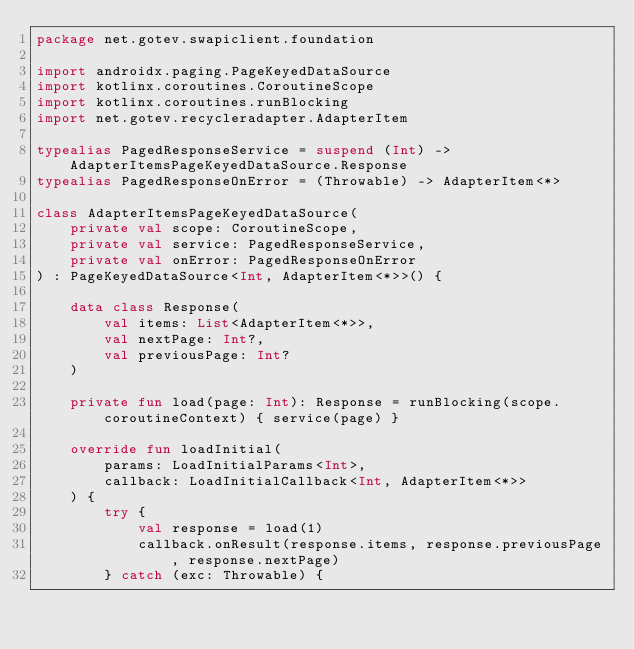<code> <loc_0><loc_0><loc_500><loc_500><_Kotlin_>package net.gotev.swapiclient.foundation

import androidx.paging.PageKeyedDataSource
import kotlinx.coroutines.CoroutineScope
import kotlinx.coroutines.runBlocking
import net.gotev.recycleradapter.AdapterItem

typealias PagedResponseService = suspend (Int) -> AdapterItemsPageKeyedDataSource.Response
typealias PagedResponseOnError = (Throwable) -> AdapterItem<*>

class AdapterItemsPageKeyedDataSource(
    private val scope: CoroutineScope,
    private val service: PagedResponseService,
    private val onError: PagedResponseOnError
) : PageKeyedDataSource<Int, AdapterItem<*>>() {

    data class Response(
        val items: List<AdapterItem<*>>,
        val nextPage: Int?,
        val previousPage: Int?
    )

    private fun load(page: Int): Response = runBlocking(scope.coroutineContext) { service(page) }

    override fun loadInitial(
        params: LoadInitialParams<Int>,
        callback: LoadInitialCallback<Int, AdapterItem<*>>
    ) {
        try {
            val response = load(1)
            callback.onResult(response.items, response.previousPage, response.nextPage)
        } catch (exc: Throwable) {</code> 